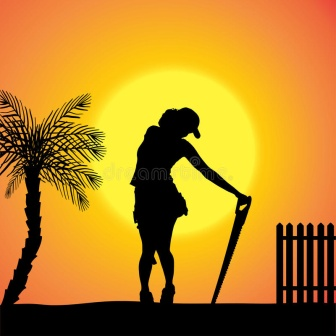Imagine this scene set on a distant, fertile planet with unique flora and fauna. Describe it. On the distant planet of Elara, this tranquil scene transforms into an otherworldly vista. The sun, twice the size of Earth's, casts a radiant glow of deep purple and gold hues across the sky. The silhouette, now an Elaran farmer, leans on a bio-shovel used to cultivate the nutrient-rich soil teeming with bioluminescent plants that glow softly in the twilight. Beside the farmer, alien flora with iridescent leaves and exquisite, translucent petals sway gently in the evening breeze. The fence is made of silver vines that have been carefully trained to grow into a barrier. As the twin moons rise in the background, the Elaran contemplates the unique ecosystem they've spent their life nurturing, knowing that their efforts contribute to the harmony and sustainability of their beloved home. What does the Elaran farmer feed the bioluminescent plants? The Elaran farmer feeds the bioluminescent plants a special nutrient mix derived from the planet's rich mineral deposits. This formula supports the unique metabolic needs of the flora, ensuring their vibrant glow and robust growth. Additionally, the plants absorb energy from the planet's dual suns during the day, which is stored and glows through the night. The farmer also uses a biogel, rich in microorganisms that promote symbiotic relationships with the plant roots, enhancing their ability to thrive in Elara's diverse environment. 